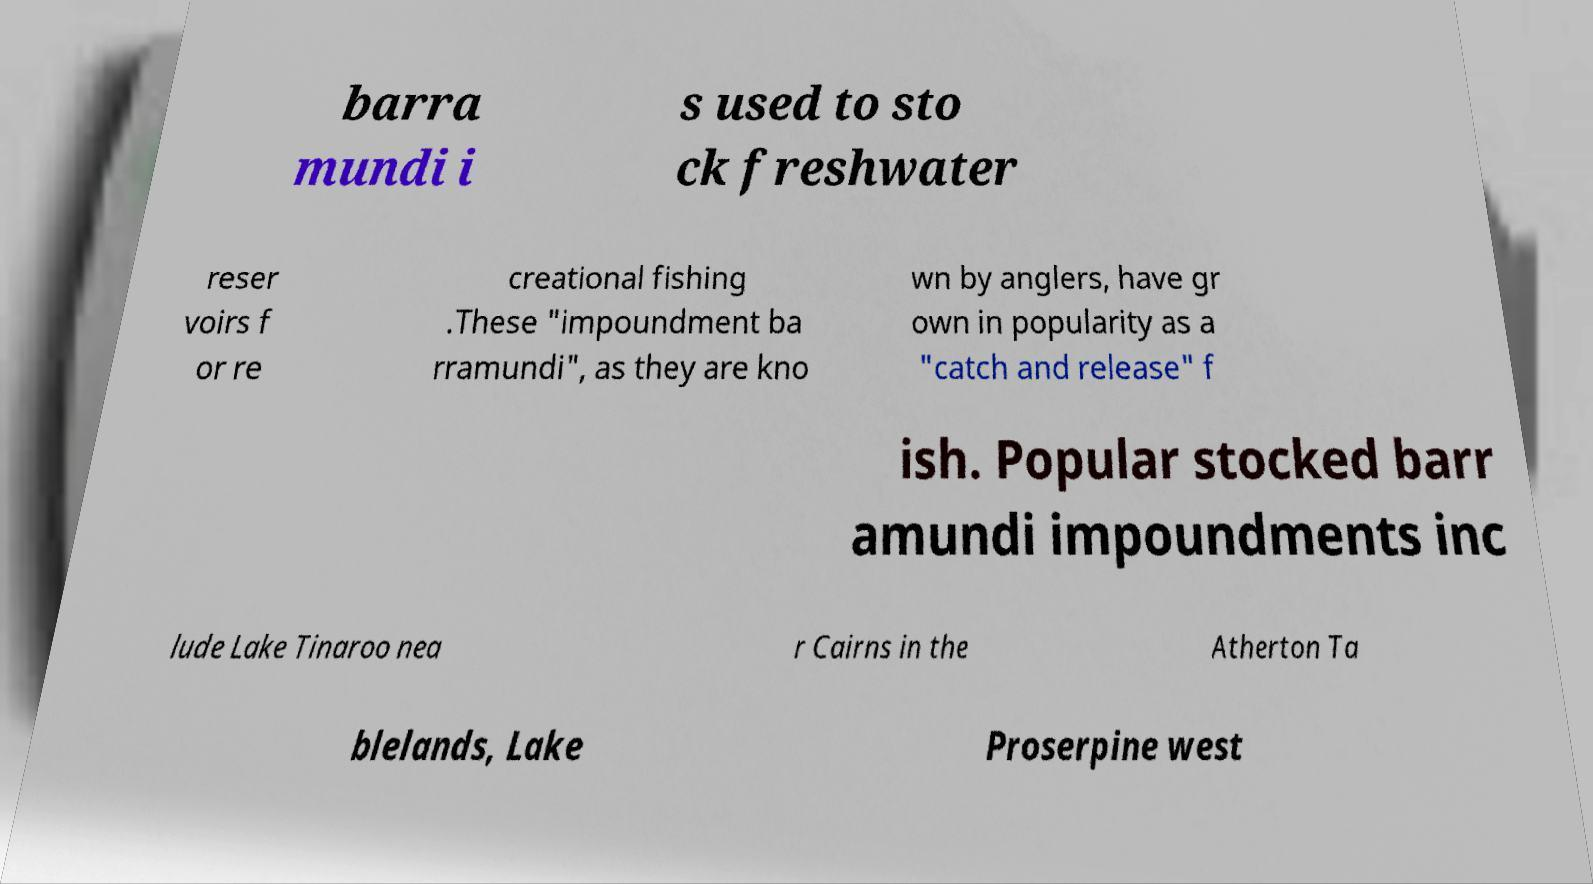Can you read and provide the text displayed in the image?This photo seems to have some interesting text. Can you extract and type it out for me? barra mundi i s used to sto ck freshwater reser voirs f or re creational fishing .These "impoundment ba rramundi", as they are kno wn by anglers, have gr own in popularity as a "catch and release" f ish. Popular stocked barr amundi impoundments inc lude Lake Tinaroo nea r Cairns in the Atherton Ta blelands, Lake Proserpine west 